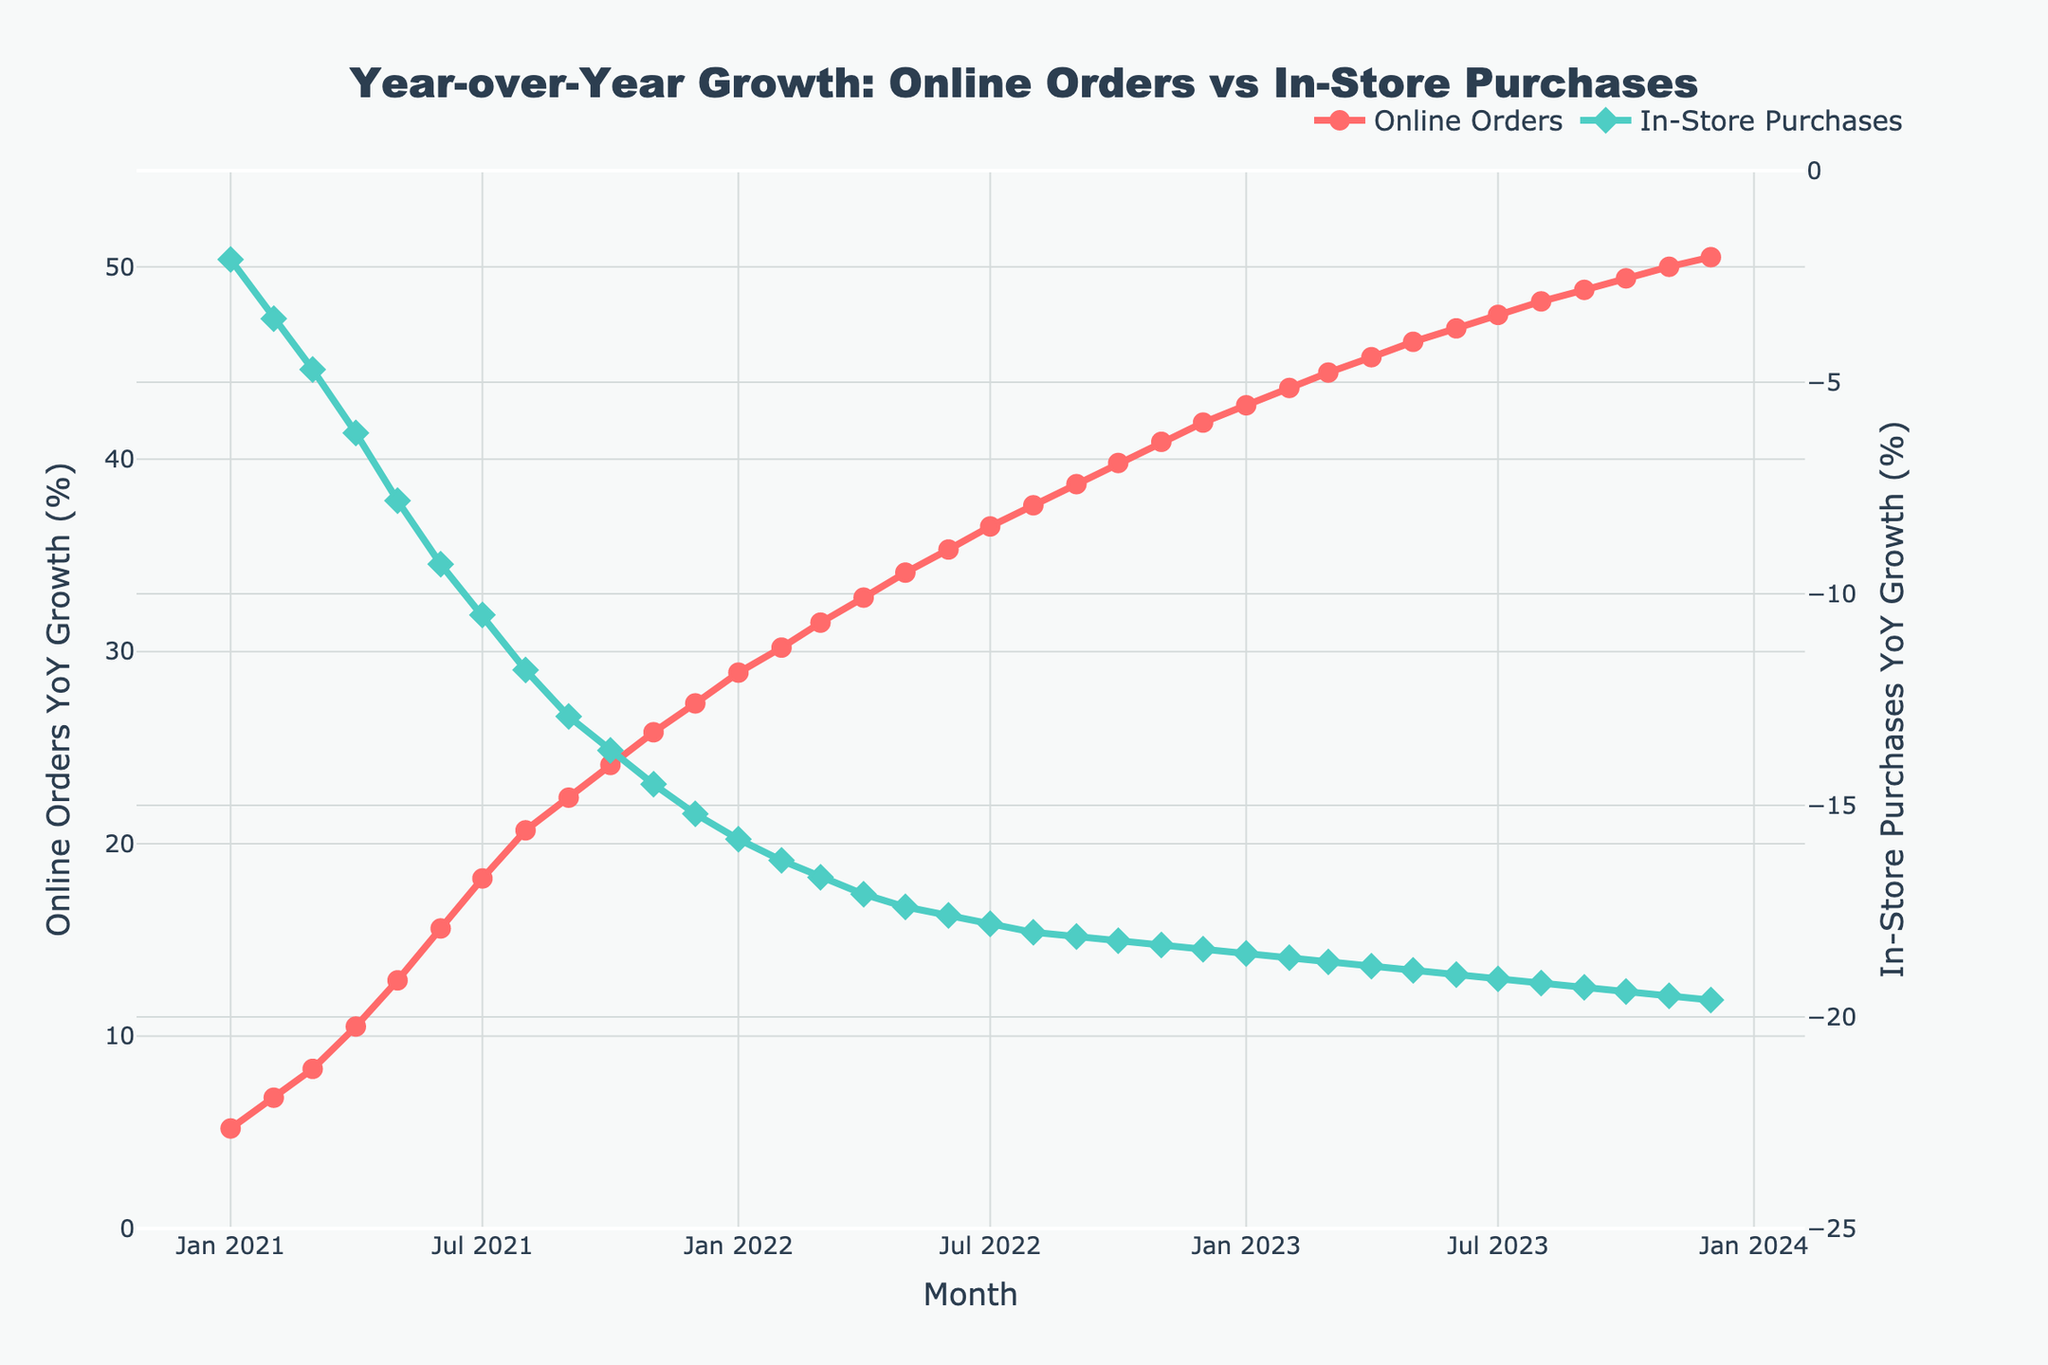What is the overall trend for online orders over the last three years? The online orders show a clear upward trend, increasing every month consistently from January 2021 through December 2023. For instance, it starts from 5.2% in January 2021 and reaches 50.5% in December 2023, showing positive growth throughout.
Answer: Upward trend How does the year-over-year growth in in-store purchases change from January 2021 to December 2023? The in-store purchases show a consistent downward trend over the period. It starts from -2.1% in January 2021 and ends at -19.6% in December 2023, showing a steady decrease each month.
Answer: Downward trend Compare the growth rates of online orders and in-store purchases in January 2021. In January 2021, online orders had a growth rate of 5.2%, whereas in-store purchases had a growth rate of -2.1%. This indicates online orders grew while in-store purchases declined.
Answer: Online Orders: 5.2%, In-Store Purchases: -2.1% By how much did online orders' year-over-year growth rate increase from January 2022 to January 2023? The year-over-year growth rate for online orders in January 2022 was 28.9%, and in January 2023 it was 42.8%. The increase is calculated as 42.8% - 28.9% = 13.9%.
Answer: 13.9% During which month and year did online orders reach a year-over-year growth rate of approximately 30%? The growth rate for online orders reached approximately 30% in February 2022, where it was 30.2%.
Answer: February 2022 Which month in 2023 shows the largest difference in growth rates between online orders and in-store purchases? In November 2023, online orders had a growth rate of 50.0% and in-store purchases had a growth rate of -19.5%. The difference is
Answer: November 2023 What was the year-over-year growth rate for in-store purchases in June 2022? In June 2022, the year-over-year growth rate for in-store purchases was -17.6%. This negative value indicates a decrease in in-store purchases compared to the previous year.
Answer: -17.6% Compare the visual attributes (color, marker type) used to represent online orders and in-store purchases. Online orders are represented with red lines and circle markers, while in-store purchases are represented with green lines and diamond markers. This distinction helps to visually differentiate the two trends in the plot.
Answer: Online: Red and circle markers, In-Store: Green and diamond markers Calculate the average year-over-year growth rate for online orders over the entire three-year period. To find the average year-over-year growth rate for online orders, sum all the monthly growth rates from January 2021 to December 2023 and divide by the total number of months. The total sum is 1073.2, and there are 36 months, so the average is 1073.2 / 36 ≈ 29.81%.
Answer: 29.8% 